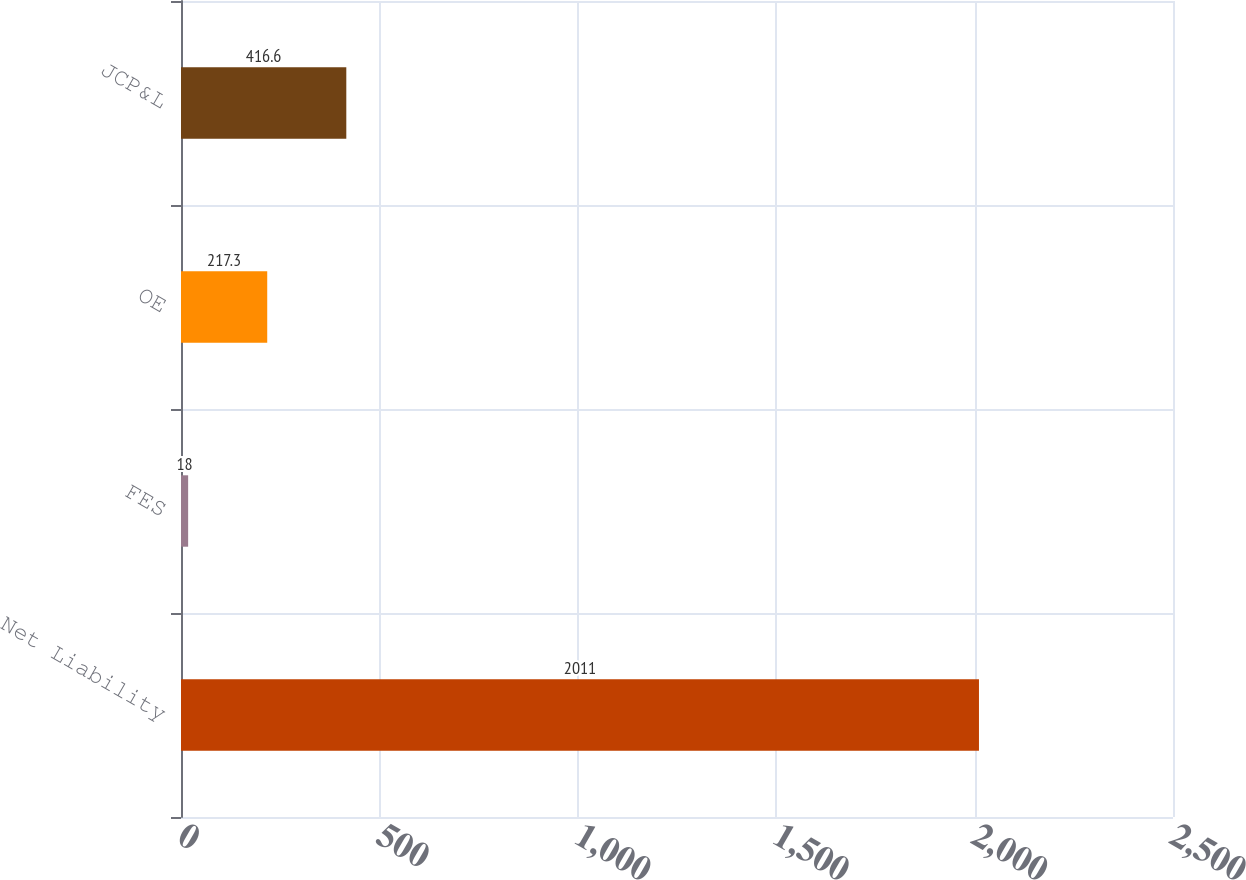Convert chart to OTSL. <chart><loc_0><loc_0><loc_500><loc_500><bar_chart><fcel>Net Liability<fcel>FES<fcel>OE<fcel>JCP&L<nl><fcel>2011<fcel>18<fcel>217.3<fcel>416.6<nl></chart> 